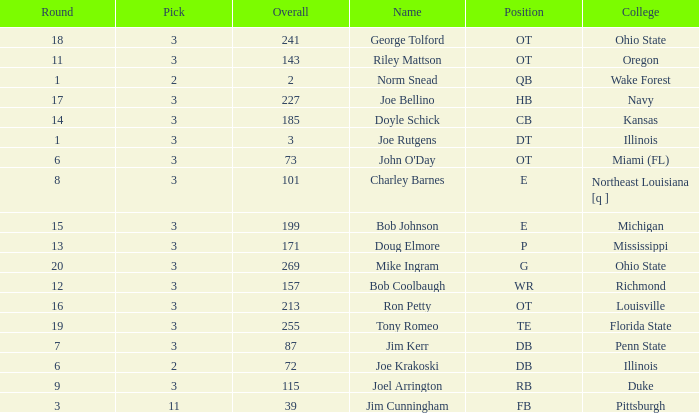How many overalls have charley barnes as the name, with a pick less than 3? None. 